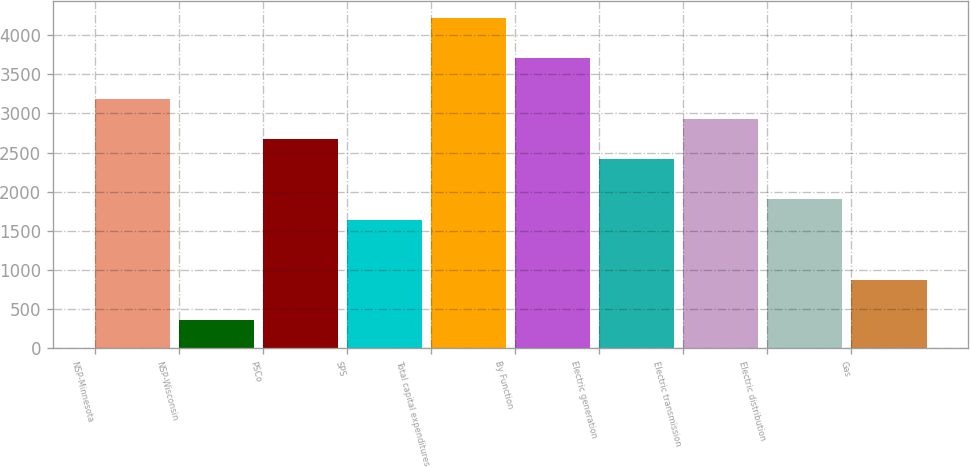<chart> <loc_0><loc_0><loc_500><loc_500><bar_chart><fcel>NSP-Minnesota<fcel>NSP-Wisconsin<fcel>PSCo<fcel>SPS<fcel>Total capital expenditures<fcel>By Function<fcel>Electric generation<fcel>Electric transmission<fcel>Electric distribution<fcel>Gas<nl><fcel>3190<fcel>357.5<fcel>2675<fcel>1645<fcel>4220<fcel>3705<fcel>2417.5<fcel>2932.5<fcel>1902.5<fcel>872.5<nl></chart> 